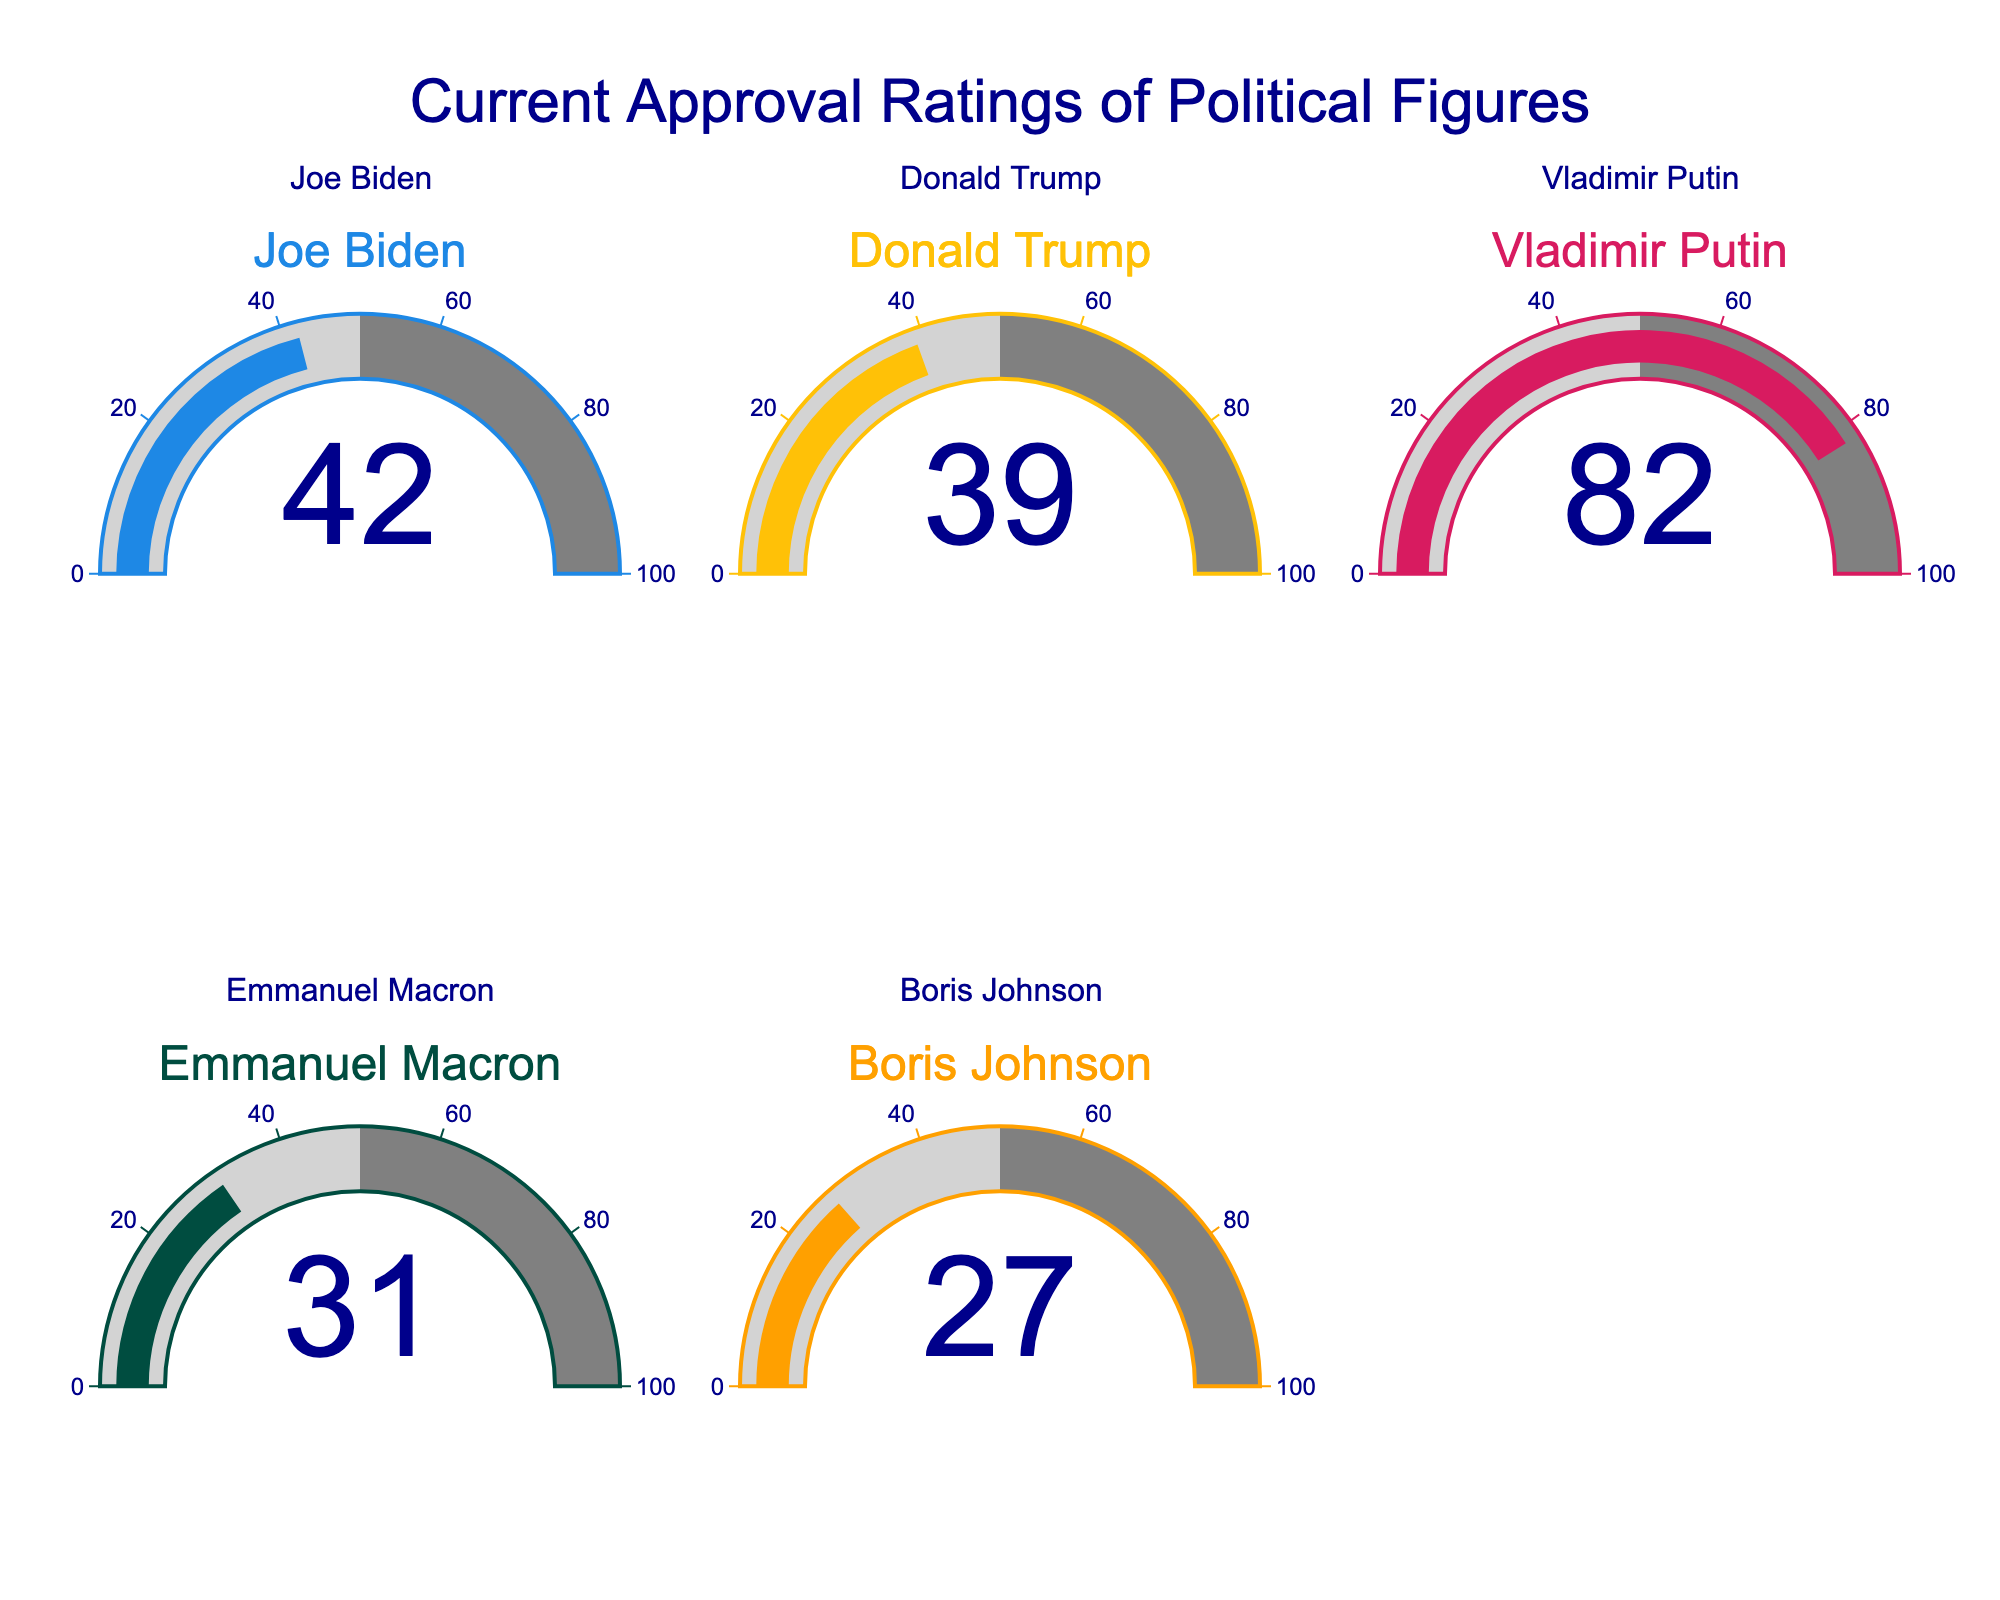What's the highest approval rating? The highest approval rating can be determined by looking at the gauge chart with the highest number displayed. In this case, Vladimir Putin has an approval rating of 82.
Answer: 82 What's the average approval rating of all the political figures? To compute the average, add all the approval ratings together and then divide by the number of figures. The sum is 42 + 39 + 82 + 31 + 27 = 221. There are 5 figures, so the average is 221 / 5 = 44.2.
Answer: 44.2 Which political figure has the lowest approval rating? The lowest approval rating can be determined by identifying the gauge chart with the smallest number displayed. In this case, Boris Johnson has an approval rating of 27.
Answer: Boris Johnson How much higher is Vladimir Putin's approval rating compared to Joe Biden's? Subtract Joe Biden's approval rating from Vladimir Putin's. 82 (Putin) - 42 (Biden) = 40.
Answer: 40 How many political figures have an approval rating below 40? Count the number of gauge charts with a number below 40. There are three: Donald Trump, Emmanuel Macron, and Boris Johnson.
Answer: 3 What is the combined approval rating of all political figures with ratings below 50? Add the approval ratings of political figures with ratings below 50. Macron (31) + Johnson (27) + Biden (42) + Trump (39) = 139.
Answer: 139 Who has a higher approval rating: Joe Biden or Donald Trump? Compare the numbers displayed on their respective gauge charts. Joe Biden has 42, which is higher than Donald Trump’s 39.
Answer: Joe Biden Is the median approval rating greater than 40? First, order the approval ratings: 27, 31, 39, 42, 82. The median is the middle number, which is 39.
Answer: No 